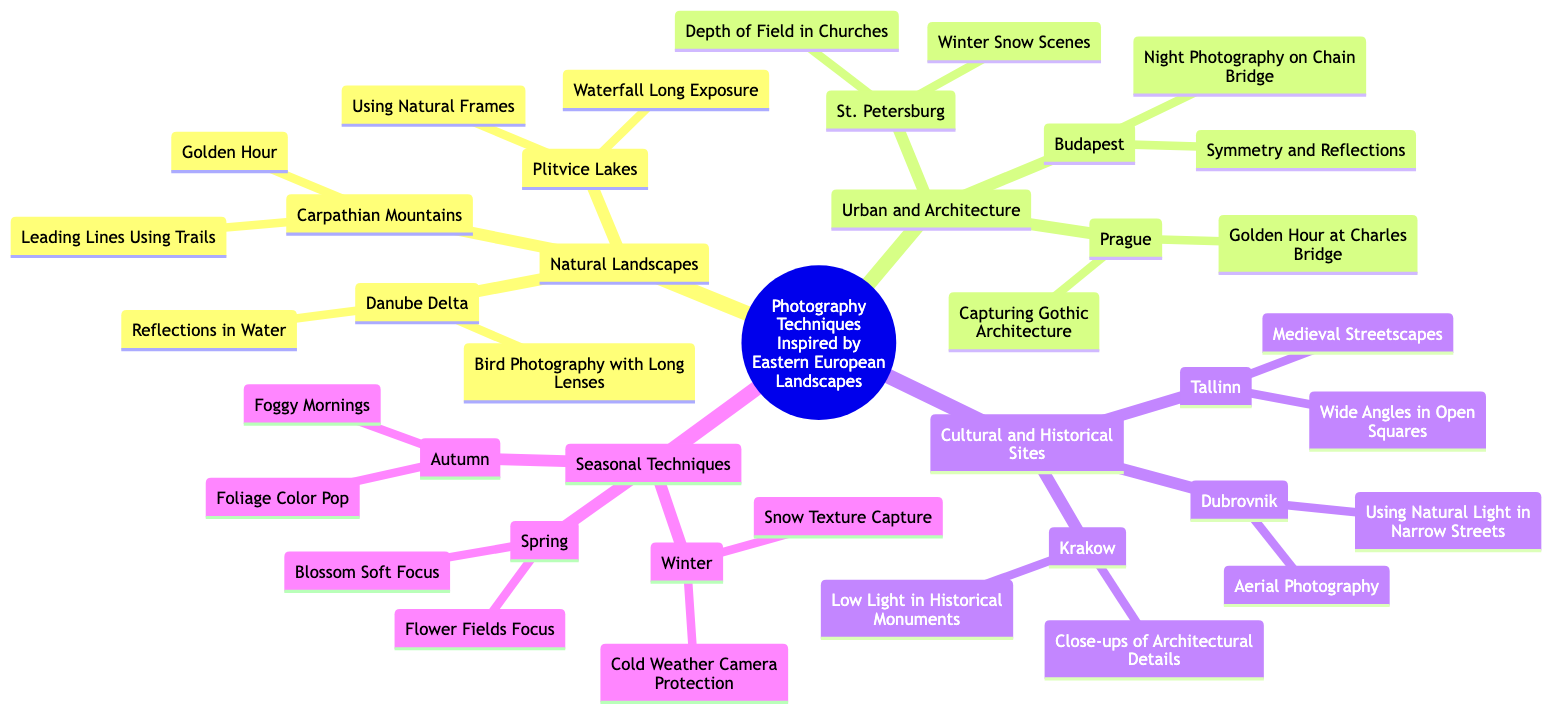What is the main topic of the mind map? The main topic is explicitly mentioned at the top of the diagram as "Photography Techniques Inspired by Eastern European Landscapes."
Answer: Photography Techniques Inspired by Eastern European Landscapes How many subtopics are there in the mind map? By counting the distinct branches from the main topic, there are four subtopics: Natural Landscapes, Urban and Architecture, Cultural and Historical Sites, and Seasonal Techniques.
Answer: 4 Which location has techniques related to "Waterfall Long Exposure"? Looking under the subtopic "Natural Landscapes," "Plitvice Lakes" can be found, which specifically lists "Waterfall Long Exposure" as one of its techniques.
Answer: Plitvice Lakes What technique is associated with Budapest? Under the "Urban and Architecture" subtopic, "Budapest" specifically lists "Night Photography on Chain Bridge."
Answer: Night Photography on Chain Bridge Which season focuses on "Foliage Color Pop"? By examining the subtopic "Seasonal Techniques," the "Autumn" section clearly states "Foliage Color Pop" as one of its techniques.
Answer: Autumn What is the relationship between Tallinn and "Medieval Streetscapes"? The location "Tallinn" is under the "Cultural and Historical Sites" subtopic and lists "Medieval Streetscapes" as one of two techniques associated with it, indicating a direct relationship where Tallinn features this photographic style.
Answer: Tallinn How many techniques are associated with St. Petersburg? The subtopic for "St. Petersburg" under "Urban and Architecture" details two techniques: "Depth of Field in Churches" and "Winter Snow Scenes," so the total count is two.
Answer: 2 Which technique involves long lenses in the Danube Delta? "Danube Delta" within the "Natural Landscapes" subtopic mentions "Bird Photography with Long Lenses" as a specific technique relevant to this location.
Answer: Bird Photography with Long Lenses Which city is linked to capturing Gothic architecture? The mind map indicates that "Prague," listed under the "Urban and Architecture" subtopic, includes the technique "Capturing Gothic Architecture."
Answer: Prague 